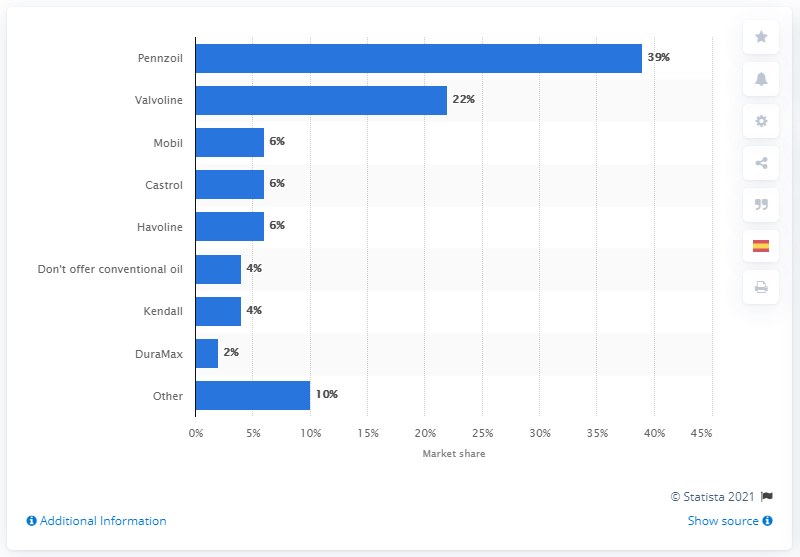Give some essential details in this illustration. Valvoline was in second place in the United States fast lubes market. In 2018, Pennzoil was the leading motor oil brand among fast lubes, according to market data. 